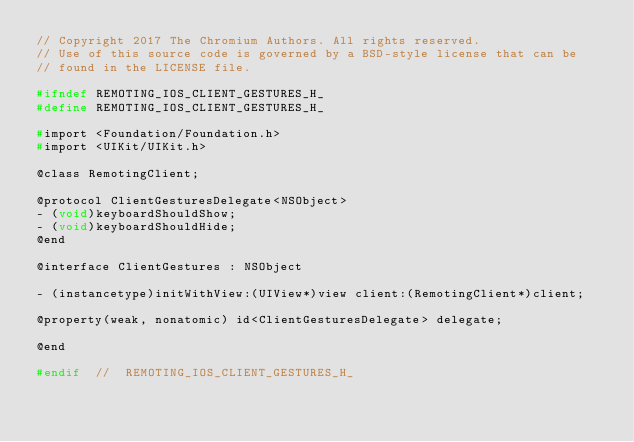<code> <loc_0><loc_0><loc_500><loc_500><_C_>// Copyright 2017 The Chromium Authors. All rights reserved.
// Use of this source code is governed by a BSD-style license that can be
// found in the LICENSE file.

#ifndef REMOTING_IOS_CLIENT_GESTURES_H_
#define REMOTING_IOS_CLIENT_GESTURES_H_

#import <Foundation/Foundation.h>
#import <UIKit/UIKit.h>

@class RemotingClient;

@protocol ClientGesturesDelegate<NSObject>
- (void)keyboardShouldShow;
- (void)keyboardShouldHide;
@end

@interface ClientGestures : NSObject

- (instancetype)initWithView:(UIView*)view client:(RemotingClient*)client;

@property(weak, nonatomic) id<ClientGesturesDelegate> delegate;

@end

#endif  //  REMOTING_IOS_CLIENT_GESTURES_H_
</code> 